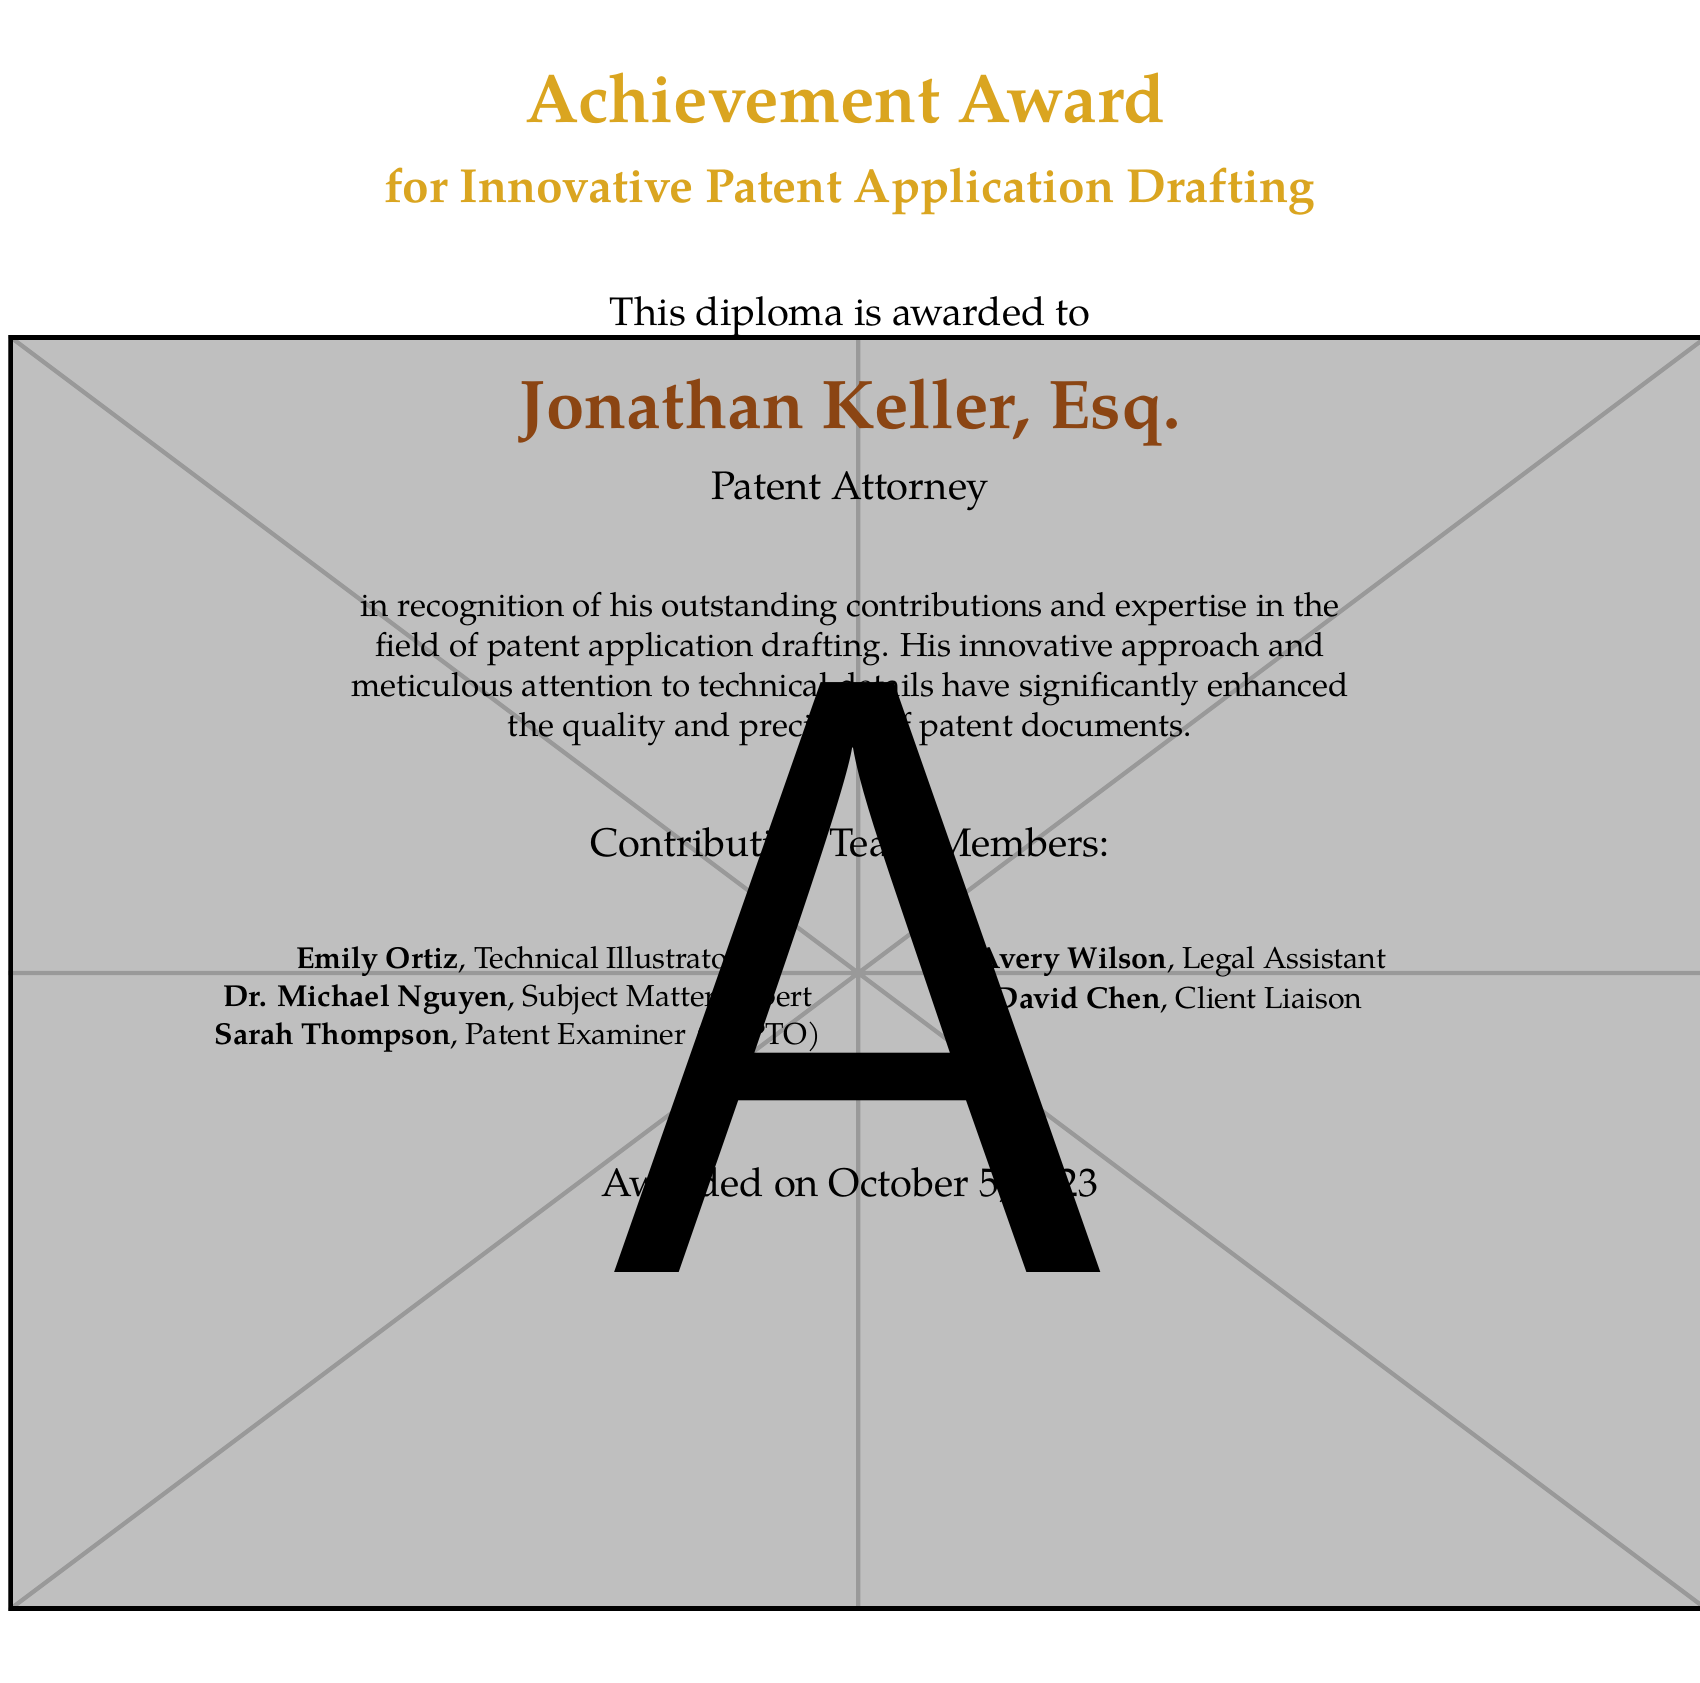What is the title of the award? The title of the award is mentioned prominently at the top of the document, which is for "Innovative Patent Application Drafting."
Answer: Innovative Patent Application Drafting Who is the diploma awarded to? The recipient’s name is clearly stated in a larger font in the center of the document.
Answer: Jonathan Keller, Esq What is the award date? The document specifies the date the award was given at the bottom.
Answer: October 5, 2023 What is the role of Emily Ortiz? Emily Ortiz’s role is listed among the Contributing Team Members.
Answer: Technical Illustrator How does the diploma describe Jonathan Keller's contributions? The description of his contributions is given in a single sentence under his name.
Answer: Outstanding contributions and expertise in the field of patent application drafting How many team members contributed to the diploma? The list of contributing team members is clearly stated on the document, which shows six individuals.
Answer: 5 What color is used for the title text? The document specifies the color used for the title text at the beginning.
Answer: Gold What position does Sarah Thompson hold? Sarah Thompson’s position is detailed in the list of contributing team members in the document.
Answer: Patent Examiner (USPTO) 